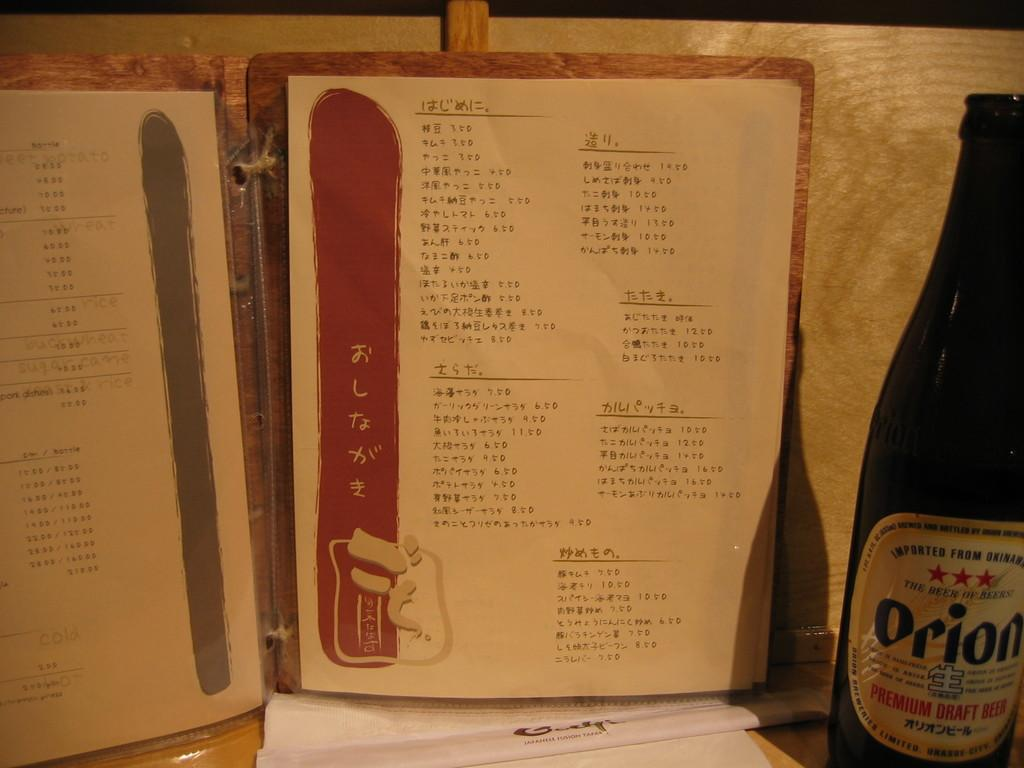<image>
Render a clear and concise summary of the photo. asian language menu and bottle of orion draft beer next to it 